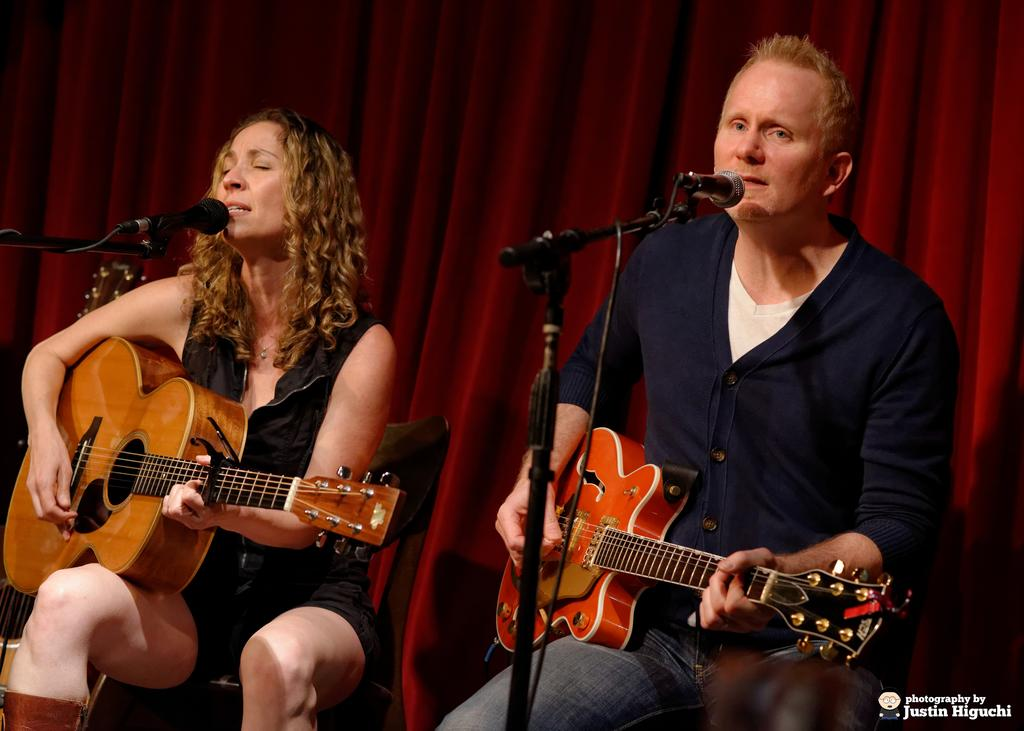How many people are in the image? There are two people in the image, a man and a woman. What are the man and woman doing in the image? The man and woman are playing guitar and singing. What are they using to amplify their voices? They are using microphones. What can be seen in the background of the image? There is a red curtain in the background of the image. How many trays can be seen on the stage in the image? There are no trays visible in the image; it features a man and a woman playing guitar and singing with microphones. Are there any spiders crawling on the red curtain in the background? There is no indication of spiders or any other creatures on the red curtain in the image. 